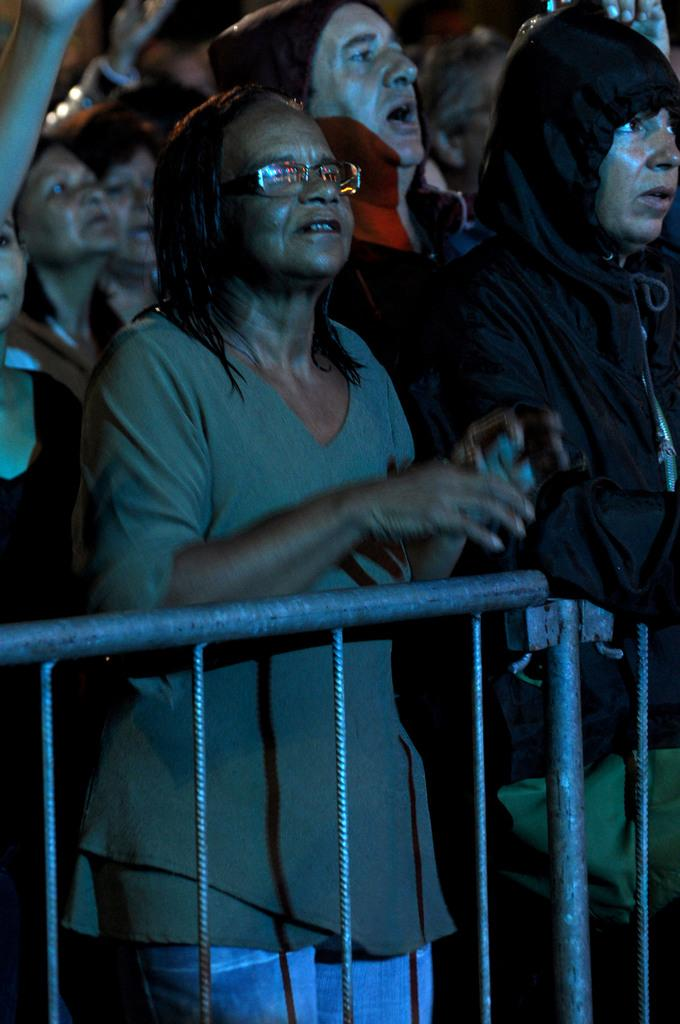What can be seen in the image that might be used for support or safety? There is a railing in the image that could be used for support or safety. What is happening in the background of the image? There is a group of people in the background of the image. Can you describe the person in the foreground of the image? In front, there is a person wearing a green and blue color dress. Where is the faucet located in the image? There is no faucet present in the image. What is the condition of the group of people in the background? The provided facts do not give information about the condition of the group of people in the background. 